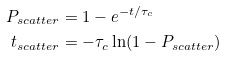<formula> <loc_0><loc_0><loc_500><loc_500>P _ { s c a t t e r } & = 1 - e ^ { - t / \tau _ { c } } \\ t _ { s c a t t e r } & = - \tau _ { c } \ln ( 1 - P _ { s c a t t e r } )</formula> 